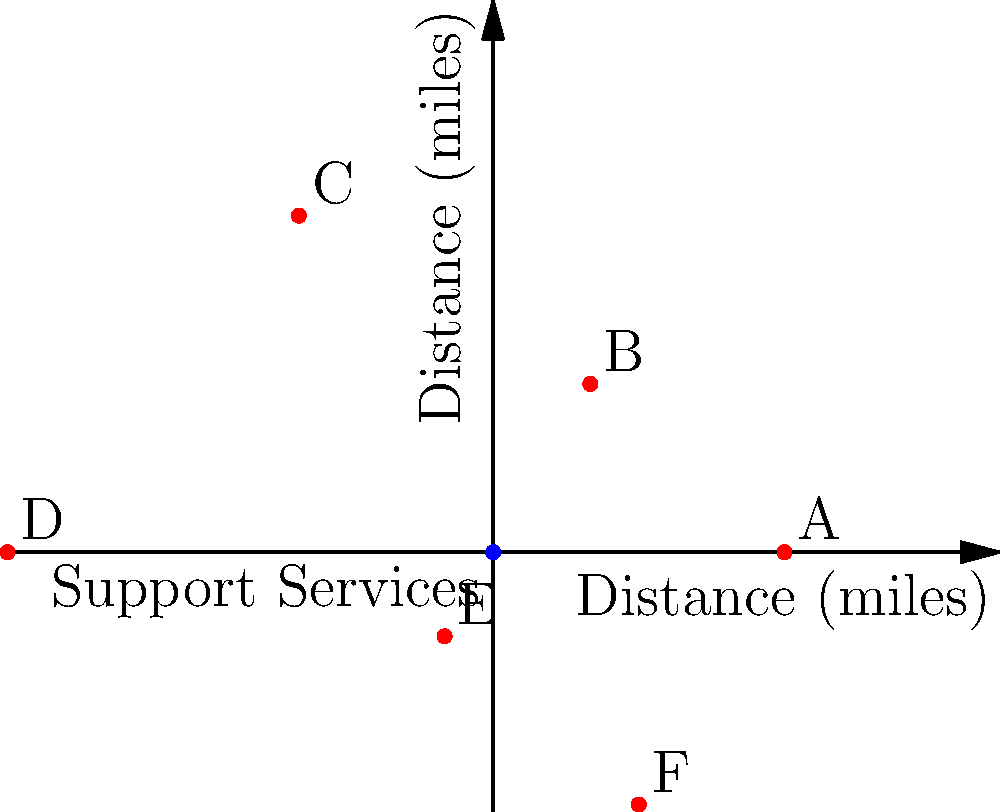The polar coordinate plot shows six housing options (A-F) relative to available support services at the origin. Which housing option is closest to the support services and what is its approximate distance? To determine which housing option is closest to the support services and its approximate distance, we need to follow these steps:

1. Identify that the origin (0,0) represents the location of support services.
2. Observe that the distance from the origin to each point represents the distance of each housing option from the support services.
3. Compare the distances of all points from the origin:
   - Point A: approximately 3 units
   - Point B: approximately 2 units
   - Point C: approximately 4 units
   - Point D: approximately 5 units
   - Point E: approximately 1 unit
   - Point F: approximately 3 units

4. Identify the point with the shortest distance from the origin.
5. Point E has the shortest distance of approximately 1 unit.

Therefore, housing option E is closest to the support services, with an approximate distance of 1 mile.
Answer: Option E, approximately 1 mile 